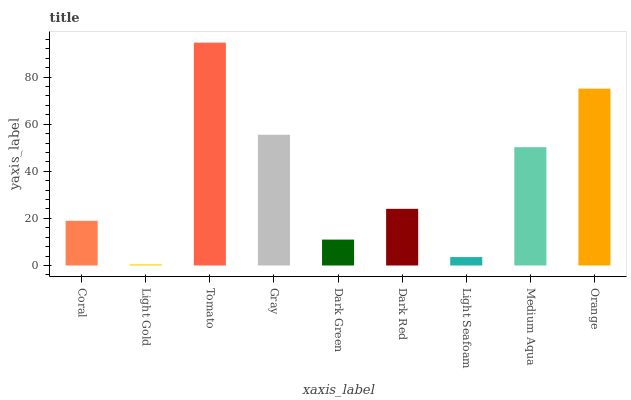Is Tomato the minimum?
Answer yes or no. No. Is Light Gold the maximum?
Answer yes or no. No. Is Tomato greater than Light Gold?
Answer yes or no. Yes. Is Light Gold less than Tomato?
Answer yes or no. Yes. Is Light Gold greater than Tomato?
Answer yes or no. No. Is Tomato less than Light Gold?
Answer yes or no. No. Is Dark Red the high median?
Answer yes or no. Yes. Is Dark Red the low median?
Answer yes or no. Yes. Is Tomato the high median?
Answer yes or no. No. Is Dark Green the low median?
Answer yes or no. No. 